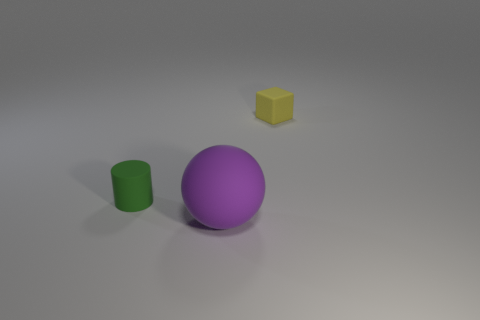Add 3 big cyan metallic cylinders. How many objects exist? 6 Subtract all large purple matte spheres. Subtract all small blocks. How many objects are left? 1 Add 1 green things. How many green things are left? 2 Add 2 tiny cyan cylinders. How many tiny cyan cylinders exist? 2 Subtract 0 purple cylinders. How many objects are left? 3 Subtract all balls. How many objects are left? 2 